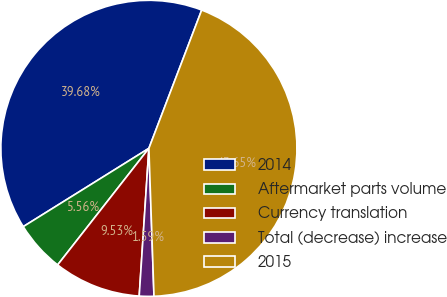<chart> <loc_0><loc_0><loc_500><loc_500><pie_chart><fcel>2014<fcel>Aftermarket parts volume<fcel>Currency translation<fcel>Total (decrease) increase<fcel>2015<nl><fcel>39.68%<fcel>5.56%<fcel>9.53%<fcel>1.59%<fcel>43.65%<nl></chart> 